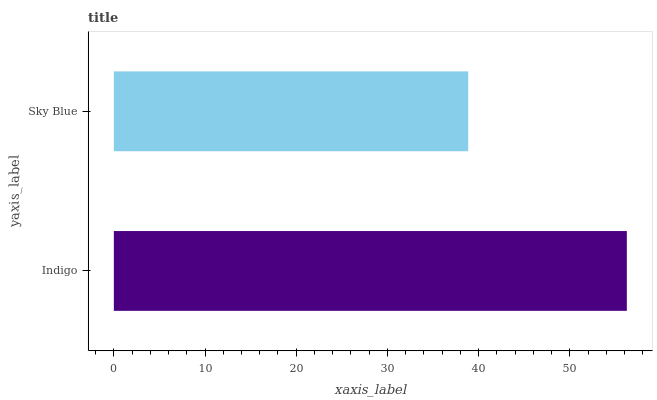Is Sky Blue the minimum?
Answer yes or no. Yes. Is Indigo the maximum?
Answer yes or no. Yes. Is Sky Blue the maximum?
Answer yes or no. No. Is Indigo greater than Sky Blue?
Answer yes or no. Yes. Is Sky Blue less than Indigo?
Answer yes or no. Yes. Is Sky Blue greater than Indigo?
Answer yes or no. No. Is Indigo less than Sky Blue?
Answer yes or no. No. Is Indigo the high median?
Answer yes or no. Yes. Is Sky Blue the low median?
Answer yes or no. Yes. Is Sky Blue the high median?
Answer yes or no. No. Is Indigo the low median?
Answer yes or no. No. 